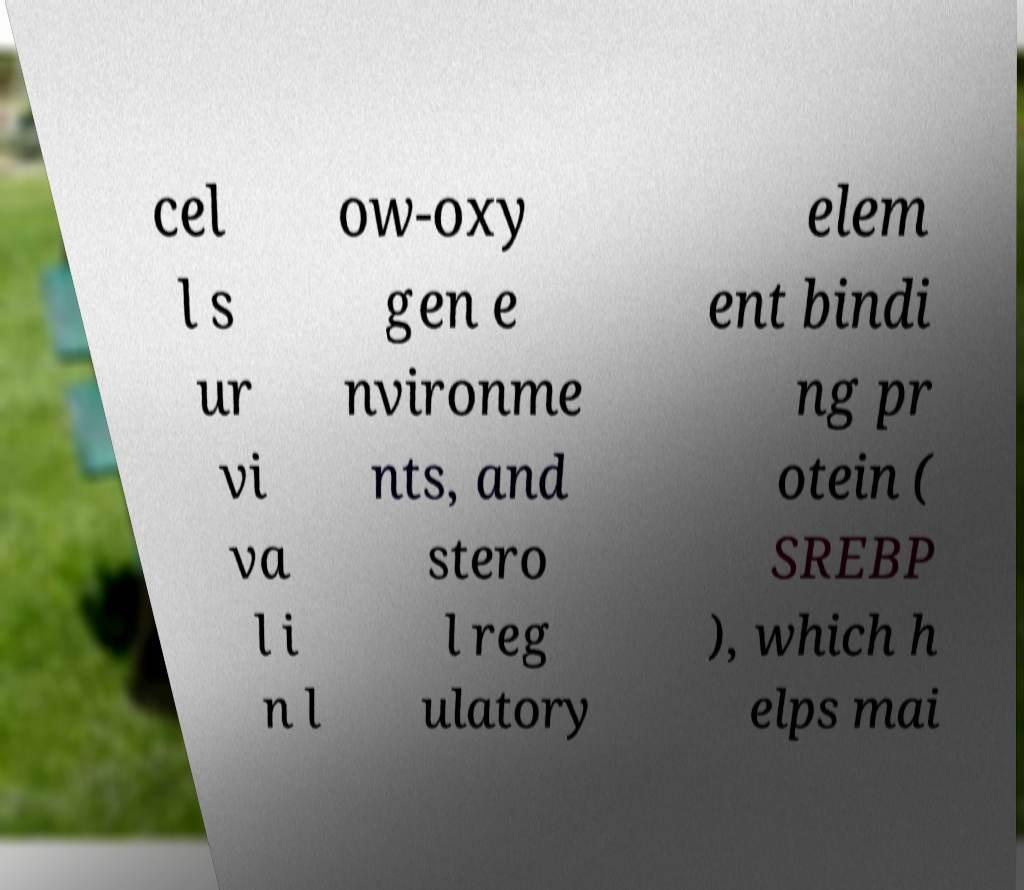Can you accurately transcribe the text from the provided image for me? cel l s ur vi va l i n l ow-oxy gen e nvironme nts, and stero l reg ulatory elem ent bindi ng pr otein ( SREBP ), which h elps mai 